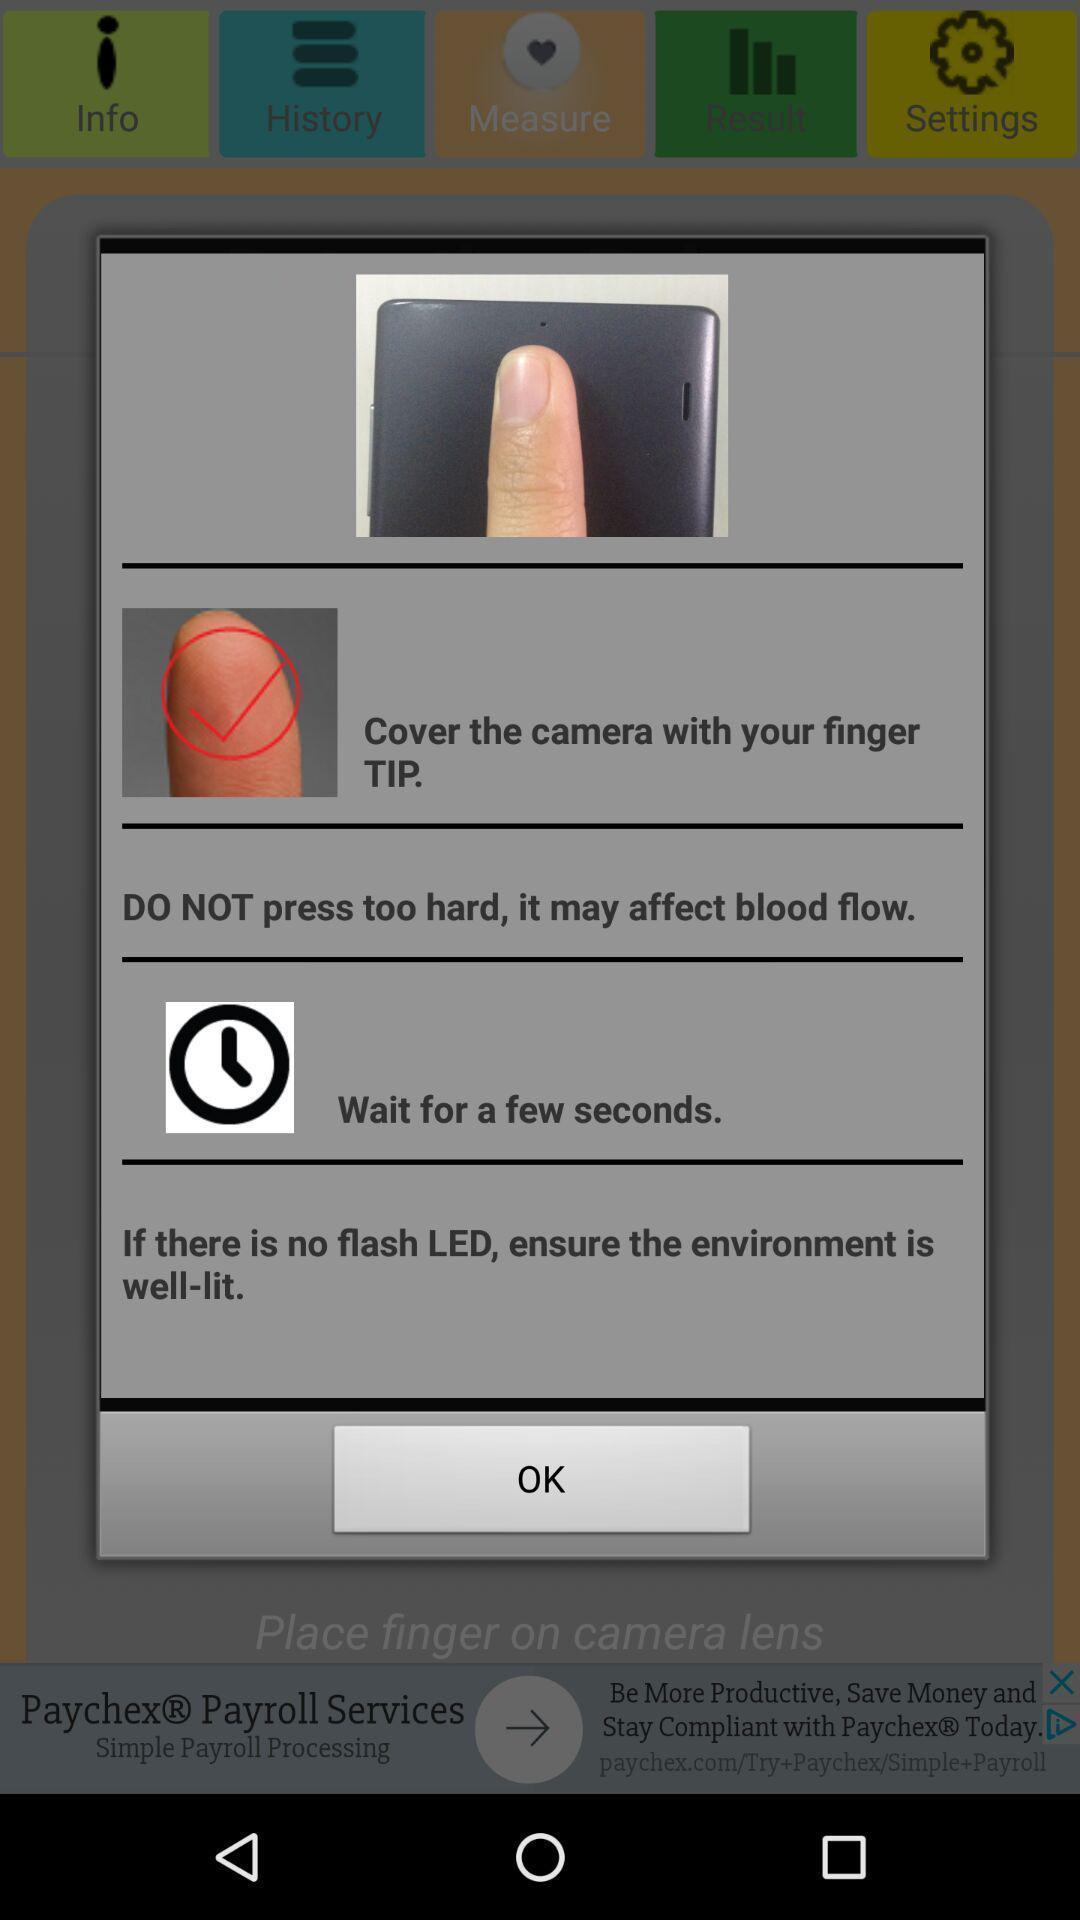Provide a textual representation of this image. Pop-up shows finger scanning details. 